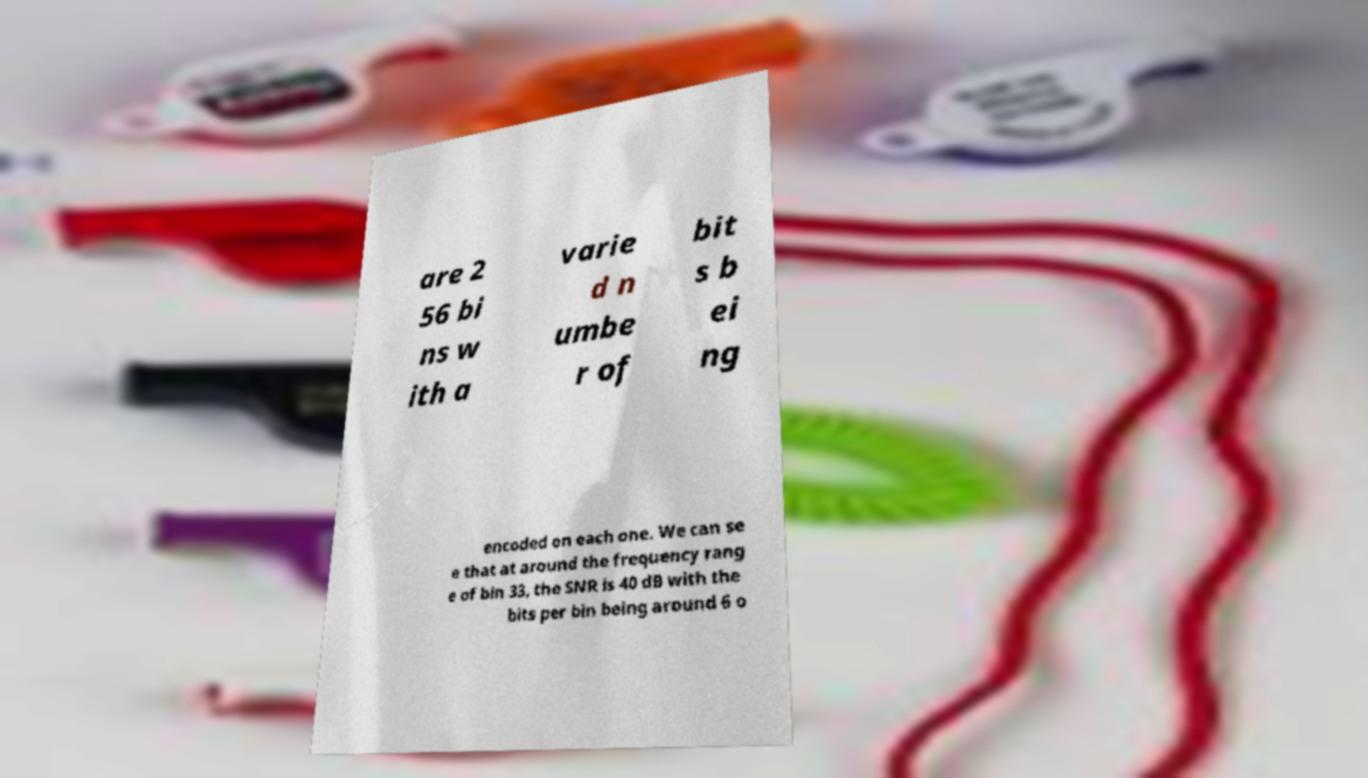What messages or text are displayed in this image? I need them in a readable, typed format. are 2 56 bi ns w ith a varie d n umbe r of bit s b ei ng encoded on each one. We can se e that at around the frequency rang e of bin 33, the SNR is 40 dB with the bits per bin being around 6 o 